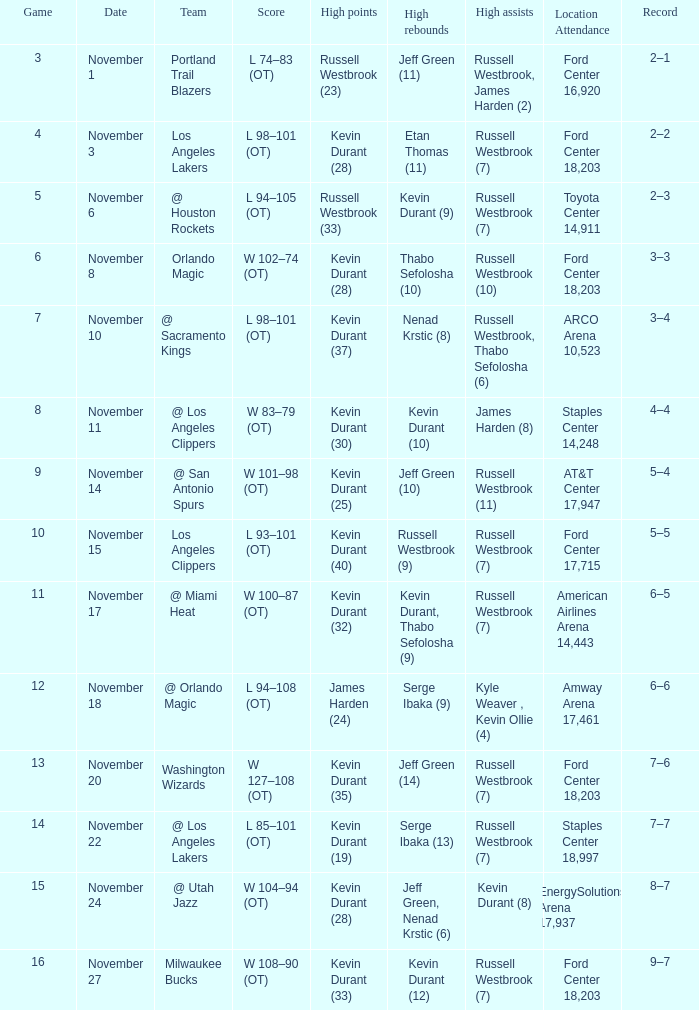What was the date of the game number 3? November 1. 